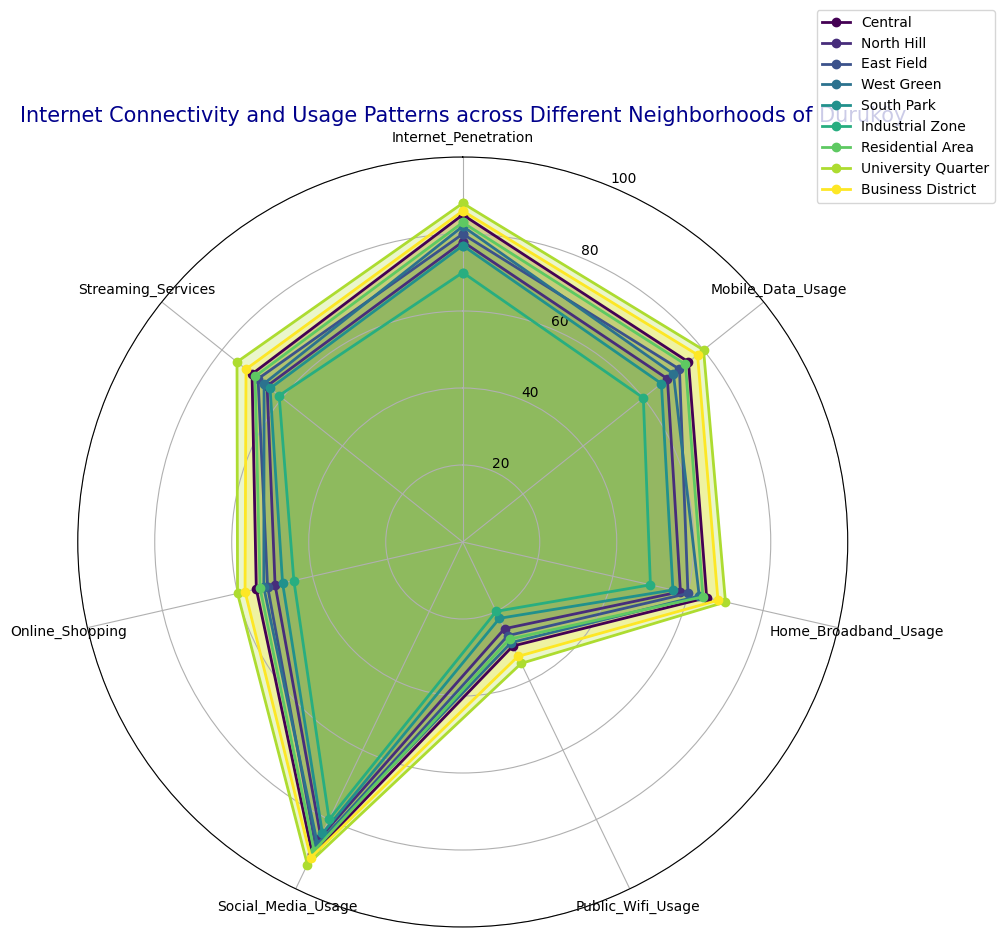How does the Internet penetration in University Quarter compare with the Industrial Zone? The University Quarter has an Internet penetration indicated by a larger segment on the radar chart compared to the Industrial Zone. Upon checking the data, the University Quarter has 88% Internet penetration while the Industrial Zone has 70%, showing a higher Internet penetration in the University Quarter.
Answer: University Quarter has 18% higher penetration Which neighborhood has the highest usage of streaming services? The neighborhood with the highest usage of streaming services will have the outermost segment in the 'Streaming Services' attribute on the radar chart. According to the data, the University Quarter shows the highest streaming services usage at 75%.
Answer: University Quarter What is the average home broadband usage across all neighborhoods? To find the average home broadband usage, sum the usage percentages of all neighborhoods and divide by the number of neighborhoods: (65 + 58 + 60 + 63 + 56 + 50 + 64 + 70 + 68) / 9 = 61.56%.
Answer: 61.56% Compare the mobile data usage between Central and North Hill neighborhoods. Which one is higher and by how much? The radar chart shows Central slightly surpassing North Hill in the Mobile Data Usage segment. Central has 75%, while North Hill has 68%, thus Central is higher by 7%.
Answer: Central by 7% Which neighborhood shows the least public WiFi usage and what is the percentage? The least public WiFi usage is indicated by the smallest segment in the 'Public_Wifi_Usage' attribute on the radar chart. The Industrial Zone, with a usage of 20%, has the smallest segment.
Answer: Industrial Zone with 20% If a person is interested in online shopping, which neighborhood would be the second best option after University Quarter? The radar chart indicates the University Quarter as having the highest online shopping percentage. Checking other data for the second highest, Business District has the next highest online shopping usage at 58%.
Answer: Business District Calculate the difference in social media usage between South Park and Business District. Which one is higher? The radar chart shows Business District having a slightly larger segment for Social Media Usage than South Park. Data reveals Business District at 91% and South Park at 84%, so Business District is higher by 7%.
Answer: Business District by 7% Which neighborhoods have social media usage greater than 85%? From the radar chart visualization, identifying neighborhoods with 'Social_Media_Usage' segments surpassing the 85% line includes University Quarter (93%), Business District (91%) and Central (90%).
Answer: University Quarter, Business District, Central Calculate the mean value for Mobile Data Usage across all neighborhoods. Summing all values for Mobile Data Usage: (75 + 68 + 72 + 70 + 66 + 60 + 74 + 80 + 78) and dividing by the total number of neighborhoods (9), we get: (643/9) = 71.44%.
Answer: 71.44% 